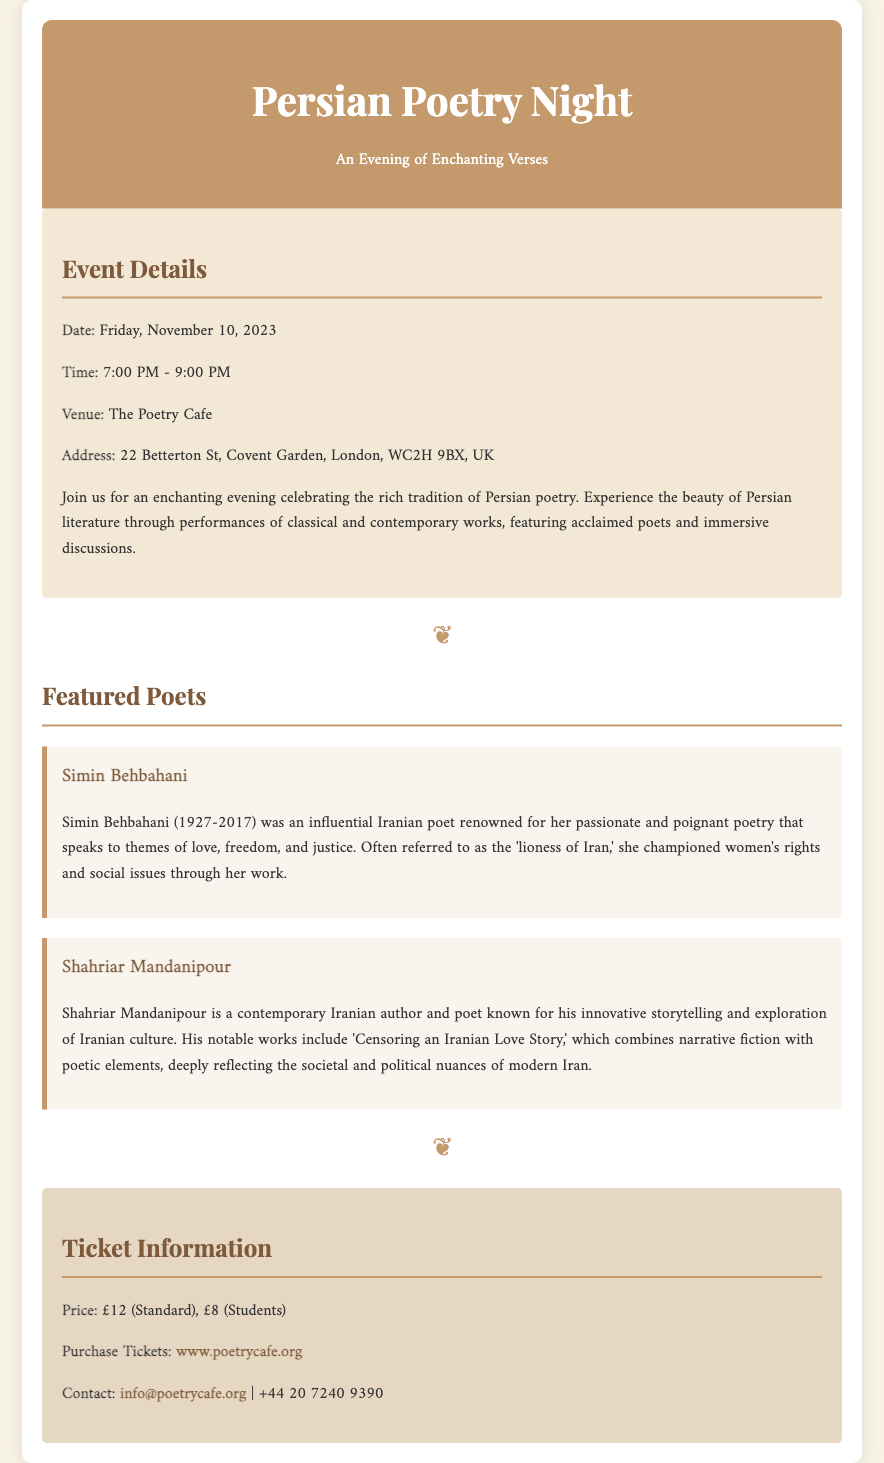What is the date of the Persian Poetry Night? The date is specifically mentioned in the event details section of the document.
Answer: Friday, November 10, 2023 What is the venue for the event? The document clearly states the venue in the event details section.
Answer: The Poetry Cafe Who is referred to as the 'lioness of Iran'? This phrase is used to describe a specific poet in the author bios section of the document.
Answer: Simin Behbahani What is the ticket price for students? The ticket prices are outlined in the ticket information section of the document.
Answer: £8 What notable work is mentioned by Shahriar Mandanipour? The document highlights a specific work in the author bios section, which is relevant to the poet's contributions.
Answer: Censoring an Iranian Love Story How long will the event last? The time frame provided in the event details informs us of the duration of the event.
Answer: 2 hours What is the contact email for inquiries? A contact email is provided within the ticket information section of the document for further questions.
Answer: info@poetrycafe.org What elements are included in the performances? The document describes the type of literature featured during the event, indicating a mix of poetry styles.
Answer: Classical and contemporary works What color is the event background? The overall background of the document is specified, influencing the visual aesthetics presented.
Answer: #f8f3e6 